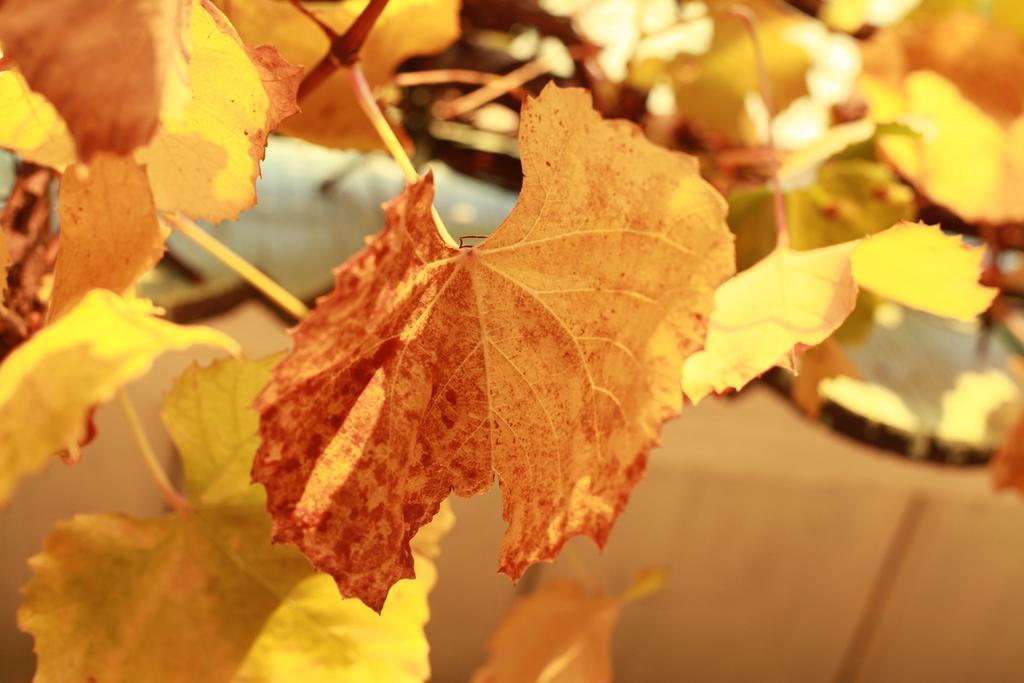In one or two sentences, can you explain what this image depicts? In this image we can see group of leaves on stems of a plant. 